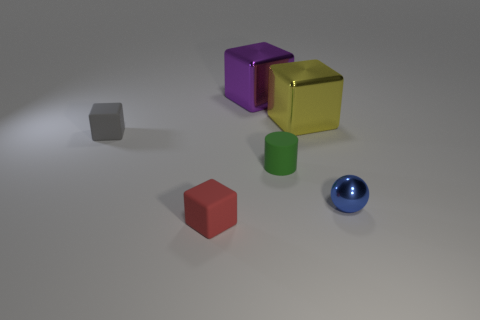Add 1 tiny blue balls. How many objects exist? 7 Subtract all balls. How many objects are left? 5 Add 2 tiny yellow shiny balls. How many tiny yellow shiny balls exist? 2 Subtract 0 yellow balls. How many objects are left? 6 Subtract all big purple blocks. Subtract all small blue shiny spheres. How many objects are left? 4 Add 2 small red cubes. How many small red cubes are left? 3 